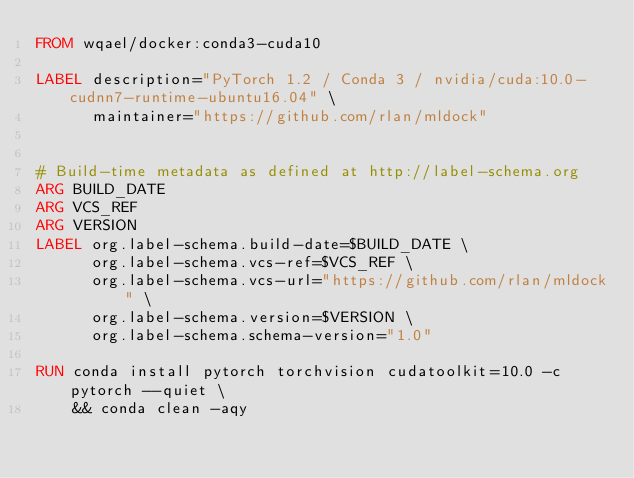Convert code to text. <code><loc_0><loc_0><loc_500><loc_500><_Dockerfile_>FROM wqael/docker:conda3-cuda10

LABEL description="PyTorch 1.2 / Conda 3 / nvidia/cuda:10.0-cudnn7-runtime-ubuntu16.04" \
      maintainer="https://github.com/rlan/mldock"


# Build-time metadata as defined at http://label-schema.org
ARG BUILD_DATE
ARG VCS_REF
ARG VERSION
LABEL org.label-schema.build-date=$BUILD_DATE \
      org.label-schema.vcs-ref=$VCS_REF \
      org.label-schema.vcs-url="https://github.com/rlan/mldock" \
      org.label-schema.version=$VERSION \
      org.label-schema.schema-version="1.0"

RUN conda install pytorch torchvision cudatoolkit=10.0 -c pytorch --quiet \
    && conda clean -aqy
</code> 